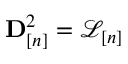Convert formula to latex. <formula><loc_0><loc_0><loc_500><loc_500>{ D } _ { [ n ] } ^ { 2 } = \mathcal { L } _ { [ n ] }</formula> 